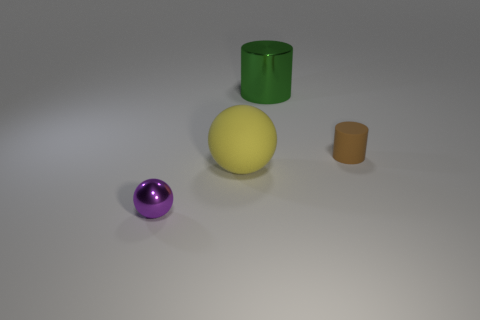What size is the metallic thing right of the ball that is behind the metal thing in front of the big ball?
Provide a short and direct response. Large. There is a matte thing that is in front of the brown cylinder; is it the same size as the small matte object?
Make the answer very short. No. What is the size of the yellow thing that is the same shape as the purple thing?
Provide a succinct answer. Large. How many other things are the same size as the purple thing?
Provide a succinct answer. 1. The brown object has what shape?
Make the answer very short. Cylinder. There is a object that is in front of the brown cylinder and behind the small purple ball; what color is it?
Your answer should be compact. Yellow. What is the material of the large ball?
Make the answer very short. Rubber. The rubber thing that is in front of the small cylinder has what shape?
Make the answer very short. Sphere. What color is the object that is the same size as the rubber cylinder?
Give a very brief answer. Purple. Is the material of the tiny object that is to the right of the large green cylinder the same as the purple object?
Provide a short and direct response. No. 